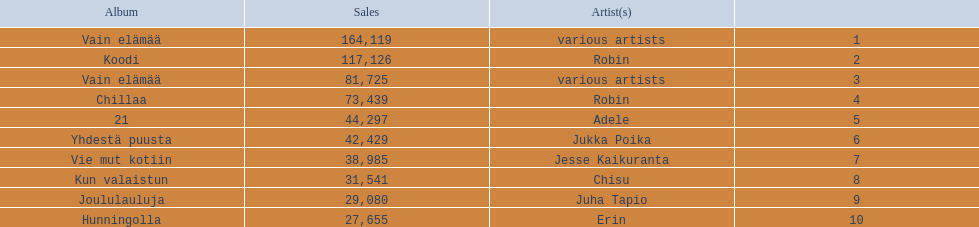Who is the artist for 21 album? Adele. Parse the full table. {'header': ['Album', 'Sales', 'Artist(s)', ''], 'rows': [['Vain elämää', '164,119', 'various artists', '1'], ['Koodi', '117,126', 'Robin', '2'], ['Vain elämää', '81,725', 'various artists', '3'], ['Chillaa', '73,439', 'Robin', '4'], ['21', '44,297', 'Adele', '5'], ['Yhdestä puusta', '42,429', 'Jukka Poika', '6'], ['Vie mut kotiin', '38,985', 'Jesse Kaikuranta', '7'], ['Kun valaistun', '31,541', 'Chisu', '8'], ['Joululauluja', '29,080', 'Juha Tapio', '9'], ['Hunningolla', '27,655', 'Erin', '10']]} Who is the artist for kun valaistun? Chisu. Which album had the same artist as chillaa? Koodi. 